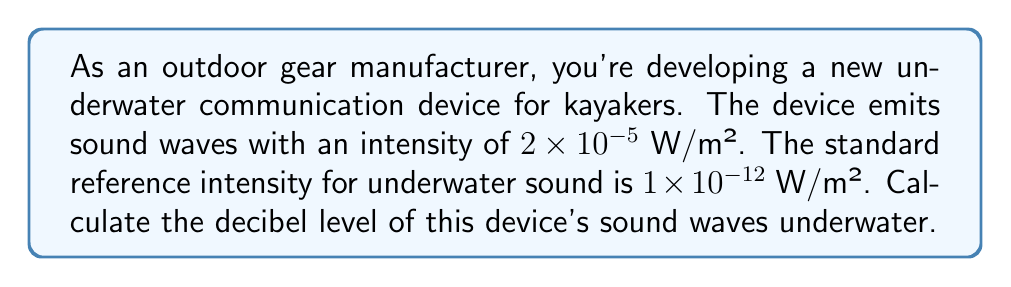Provide a solution to this math problem. To solve this problem, we'll use the formula for decibel level:

$$ \text{dB} = 10 \log_{10} \left(\frac{I}{I_0}\right) $$

Where:
- $I$ is the intensity of the sound in W/m²
- $I_0$ is the reference intensity in W/m²

Given:
- $I = 2 \times 10^{-5}$ W/m²
- $I_0 = 1 \times 10^{-12}$ W/m²

Let's substitute these values into the formula:

$$ \text{dB} = 10 \log_{10} \left(\frac{2 \times 10^{-5}}{1 \times 10^{-12}}\right) $$

Simplify the fraction inside the parentheses:

$$ \text{dB} = 10 \log_{10} (2 \times 10^7) $$

Using the properties of logarithms, we can separate this:

$$ \text{dB} = 10 (\log_{10} 2 + \log_{10} 10^7) $$

$$ \text{dB} = 10 (\log_{10} 2 + 7) $$

Calculate $\log_{10} 2 \approx 0.301$:

$$ \text{dB} = 10 (0.301 + 7) $$
$$ \text{dB} = 10 (7.301) $$
$$ \text{dB} = 73.01 $$

Rounding to the nearest whole number:

$$ \text{dB} \approx 73 $$
Answer: The decibel level of the kayak communication device's sound waves underwater is approximately 73 dB. 